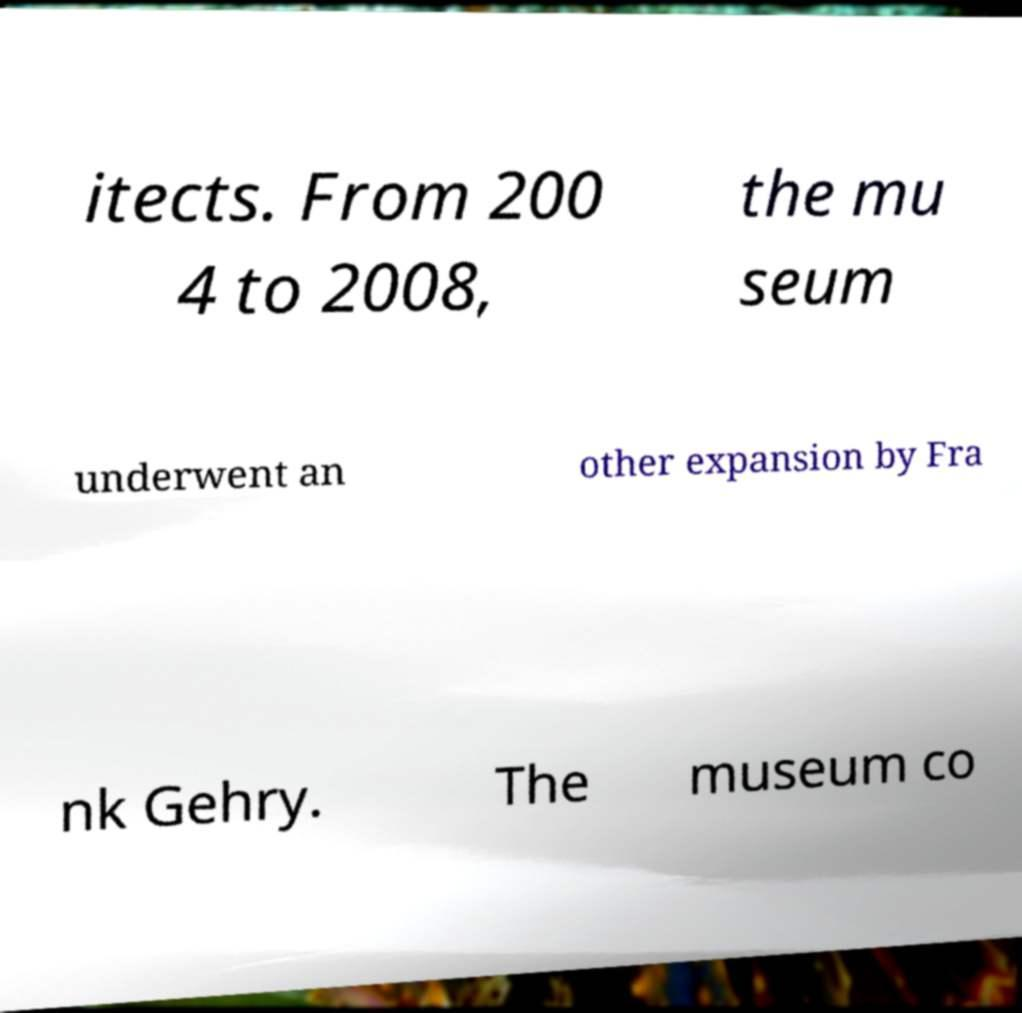Could you assist in decoding the text presented in this image and type it out clearly? itects. From 200 4 to 2008, the mu seum underwent an other expansion by Fra nk Gehry. The museum co 